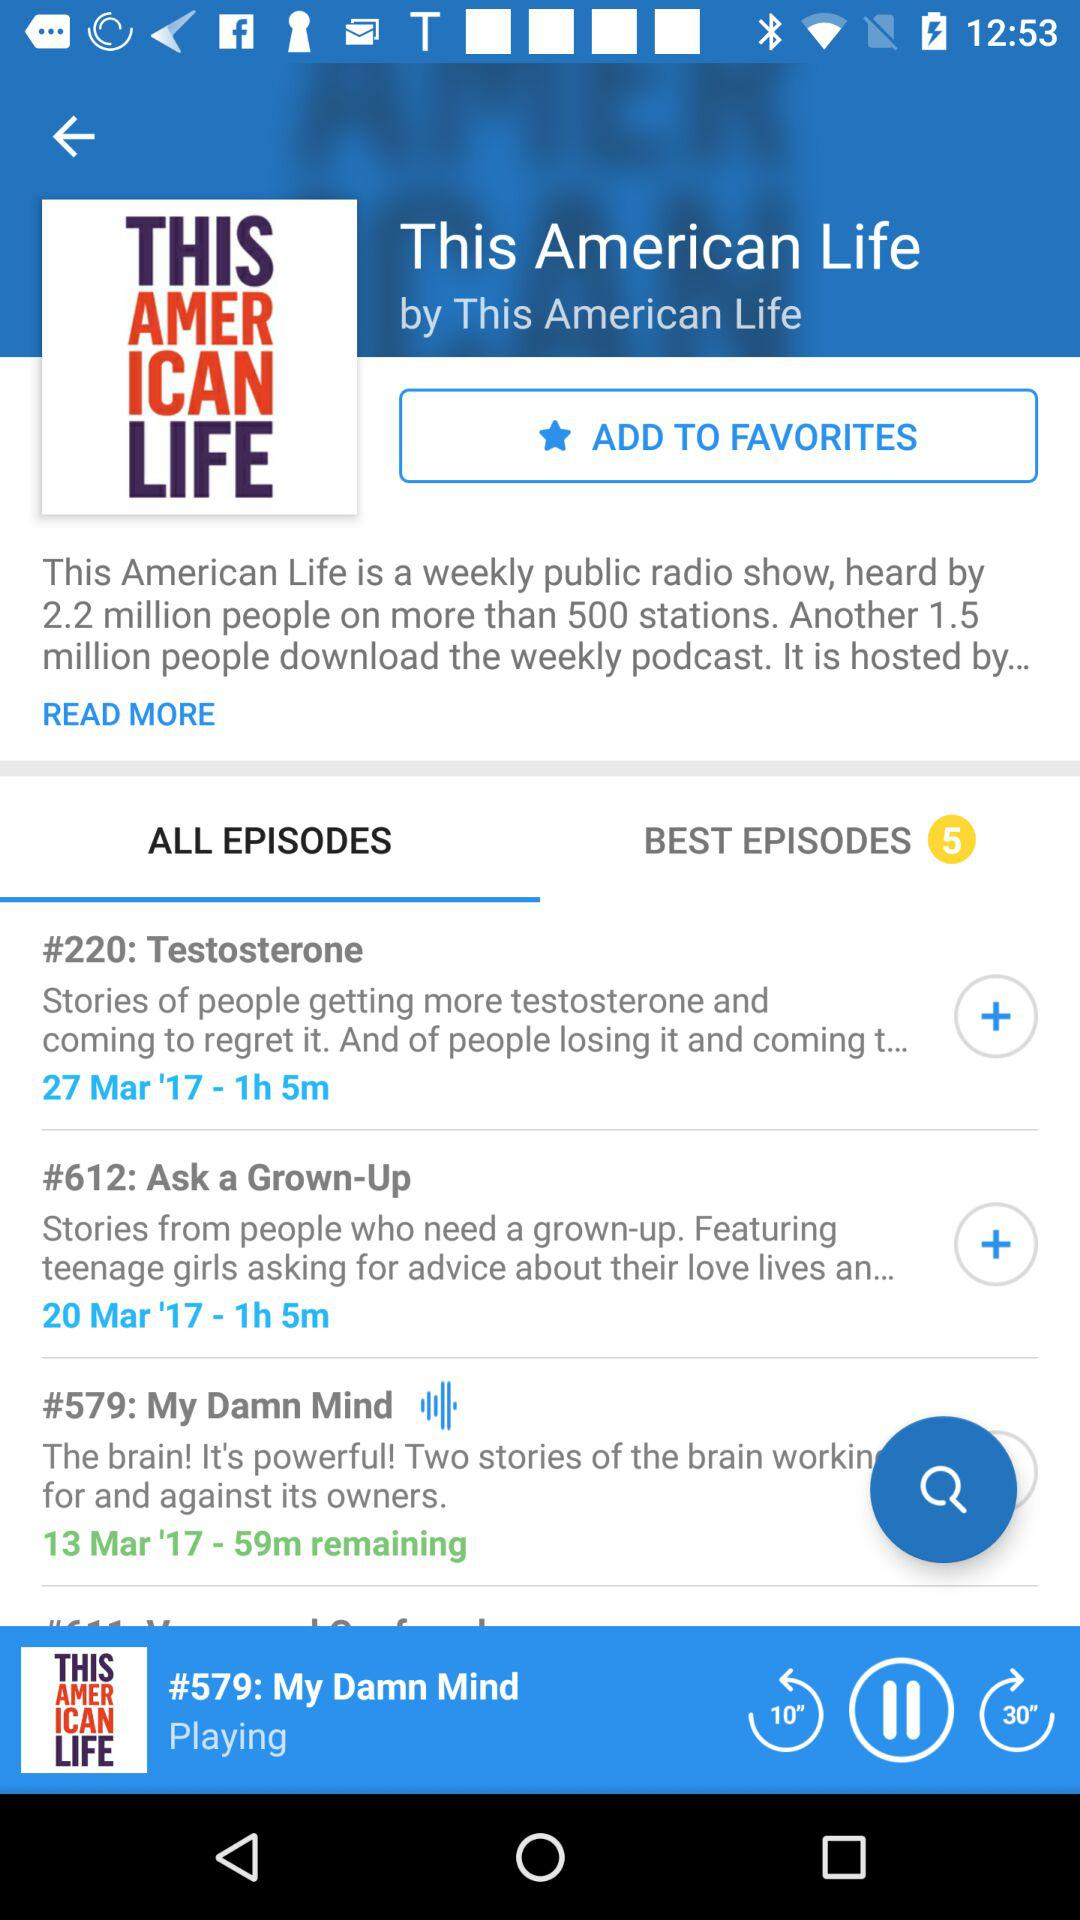What is the selected tab? The selected tab is "ALL EPISODES". 